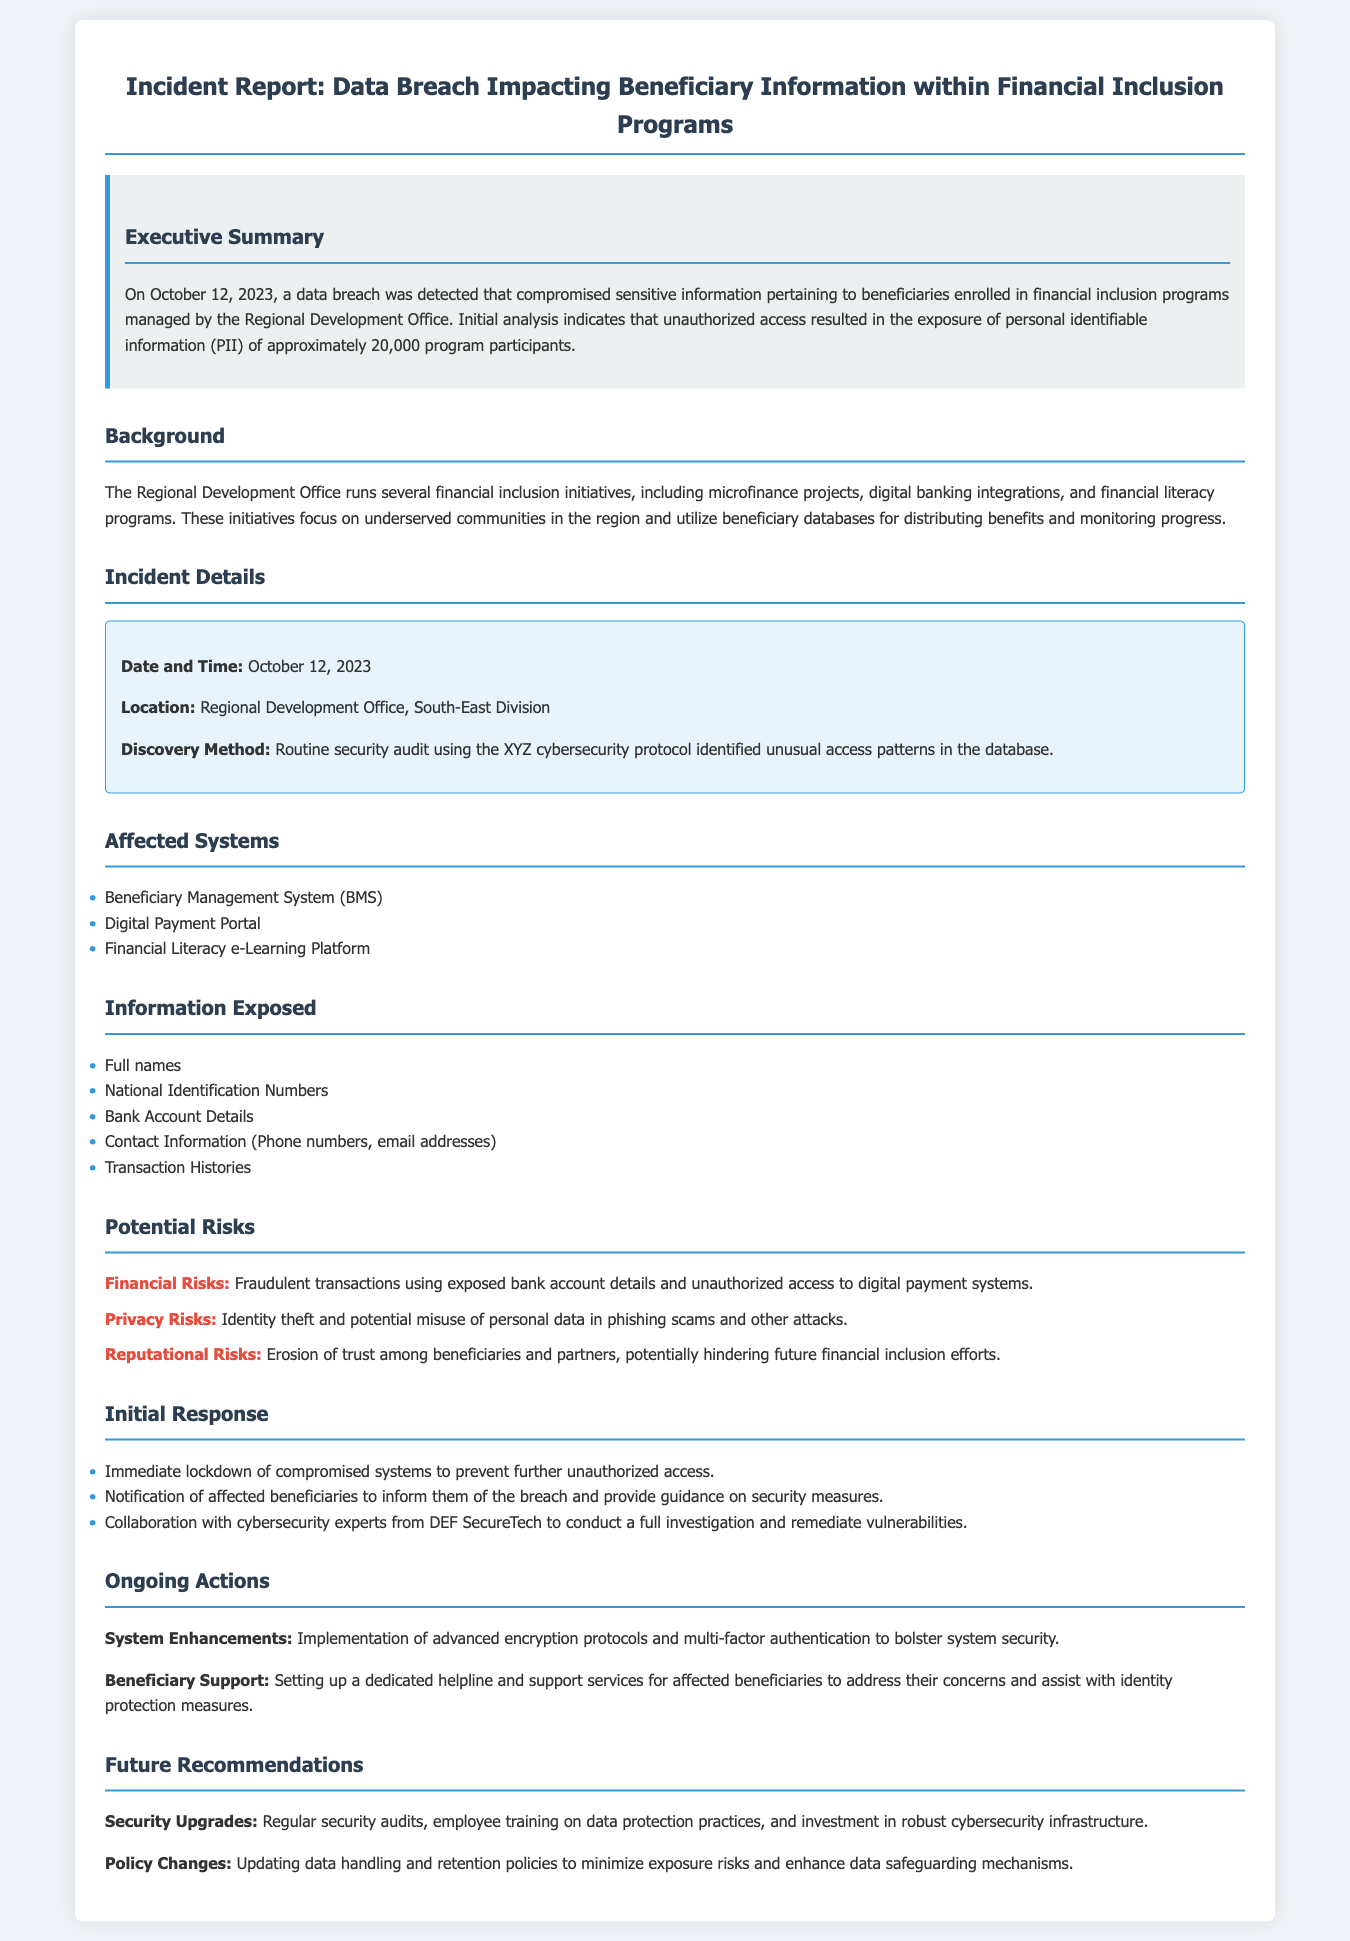What is the date of the data breach? The date of the data breach is clearly stated in the document, which is October 12, 2023.
Answer: October 12, 2023 How many beneficiaries were affected? The report mentions that approximately 20,000 program participants had their information compromised.
Answer: 20,000 What types of information were exposed? The document lists specific types of information that were compromised, including full names and national identification numbers.
Answer: Full names, National Identification Numbers, Bank Account Details, Contact Information, Transaction Histories What were the financial risks noted in the report? The report details a financial risk associated with the breach, including potential fraudulent activities.
Answer: Fraudulent transactions Which system was compromised? The document specifically mentions the Beneficiary Management System as one of the affected systems.
Answer: Beneficiary Management System (BMS) What action was taken immediately after the breach was discovered? The report states that a lockdown of the compromised systems was one of the immediate responses to the incident.
Answer: Immediate lockdown of compromised systems Who collaborated with the Regional Development Office for investigation? The report indicates collaboration with cybersecurity experts from a specific organization for investigating the breach.
Answer: DEF SecureTech What are the recommendations for future security? The document outlines a recommendation for regular security audits as a future measure to enhance security.
Answer: Regular security audits 